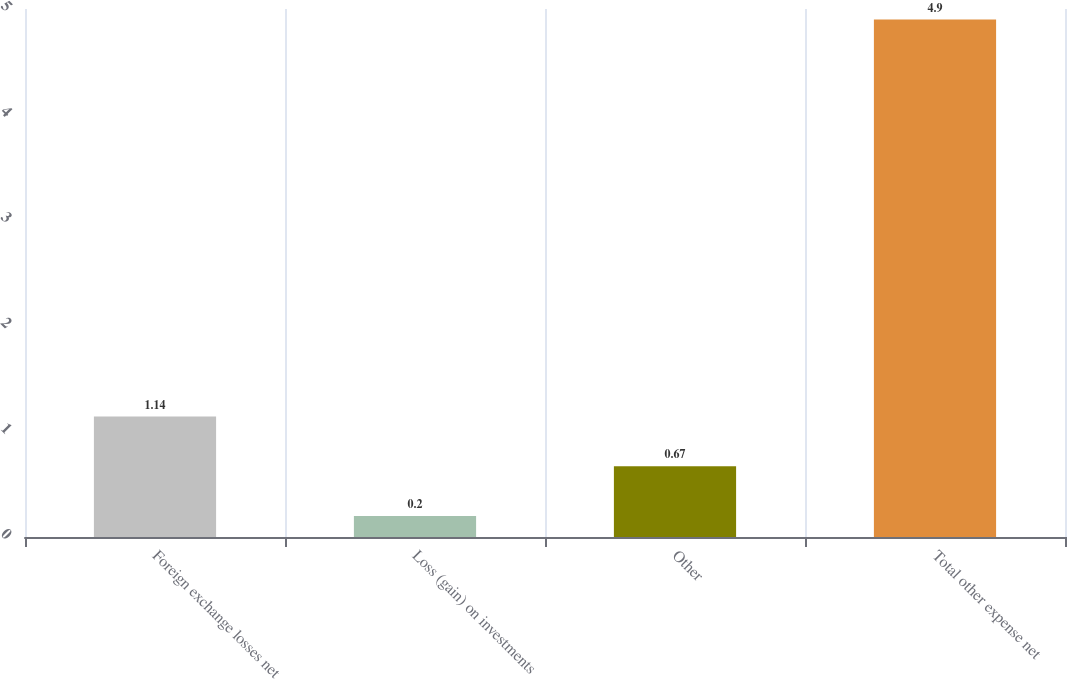Convert chart to OTSL. <chart><loc_0><loc_0><loc_500><loc_500><bar_chart><fcel>Foreign exchange losses net<fcel>Loss (gain) on investments<fcel>Other<fcel>Total other expense net<nl><fcel>1.14<fcel>0.2<fcel>0.67<fcel>4.9<nl></chart> 